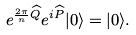<formula> <loc_0><loc_0><loc_500><loc_500>e ^ { \frac { 2 \pi } { n } \widehat { Q } } e ^ { i \widehat { P } } | 0 \rangle = | 0 \rangle .</formula> 